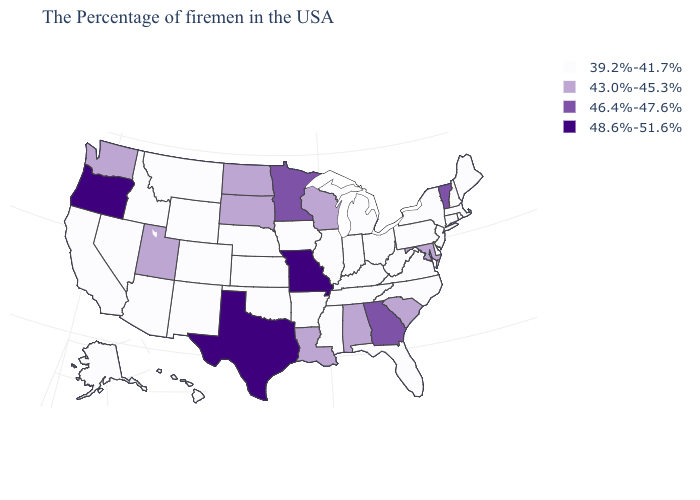Name the states that have a value in the range 43.0%-45.3%?
Concise answer only. Maryland, South Carolina, Alabama, Wisconsin, Louisiana, South Dakota, North Dakota, Utah, Washington. What is the value of Michigan?
Answer briefly. 39.2%-41.7%. What is the value of Idaho?
Short answer required. 39.2%-41.7%. What is the lowest value in the USA?
Be succinct. 39.2%-41.7%. Name the states that have a value in the range 43.0%-45.3%?
Short answer required. Maryland, South Carolina, Alabama, Wisconsin, Louisiana, South Dakota, North Dakota, Utah, Washington. Name the states that have a value in the range 39.2%-41.7%?
Keep it brief. Maine, Massachusetts, Rhode Island, New Hampshire, Connecticut, New York, New Jersey, Delaware, Pennsylvania, Virginia, North Carolina, West Virginia, Ohio, Florida, Michigan, Kentucky, Indiana, Tennessee, Illinois, Mississippi, Arkansas, Iowa, Kansas, Nebraska, Oklahoma, Wyoming, Colorado, New Mexico, Montana, Arizona, Idaho, Nevada, California, Alaska, Hawaii. Which states have the lowest value in the USA?
Keep it brief. Maine, Massachusetts, Rhode Island, New Hampshire, Connecticut, New York, New Jersey, Delaware, Pennsylvania, Virginia, North Carolina, West Virginia, Ohio, Florida, Michigan, Kentucky, Indiana, Tennessee, Illinois, Mississippi, Arkansas, Iowa, Kansas, Nebraska, Oklahoma, Wyoming, Colorado, New Mexico, Montana, Arizona, Idaho, Nevada, California, Alaska, Hawaii. Does Kentucky have the highest value in the USA?
Give a very brief answer. No. Does Alabama have the lowest value in the USA?
Short answer required. No. What is the value of California?
Keep it brief. 39.2%-41.7%. Which states have the lowest value in the MidWest?
Concise answer only. Ohio, Michigan, Indiana, Illinois, Iowa, Kansas, Nebraska. Name the states that have a value in the range 46.4%-47.6%?
Concise answer only. Vermont, Georgia, Minnesota. What is the lowest value in states that border Maryland?
Be succinct. 39.2%-41.7%. What is the lowest value in states that border West Virginia?
Short answer required. 39.2%-41.7%. Name the states that have a value in the range 43.0%-45.3%?
Give a very brief answer. Maryland, South Carolina, Alabama, Wisconsin, Louisiana, South Dakota, North Dakota, Utah, Washington. 